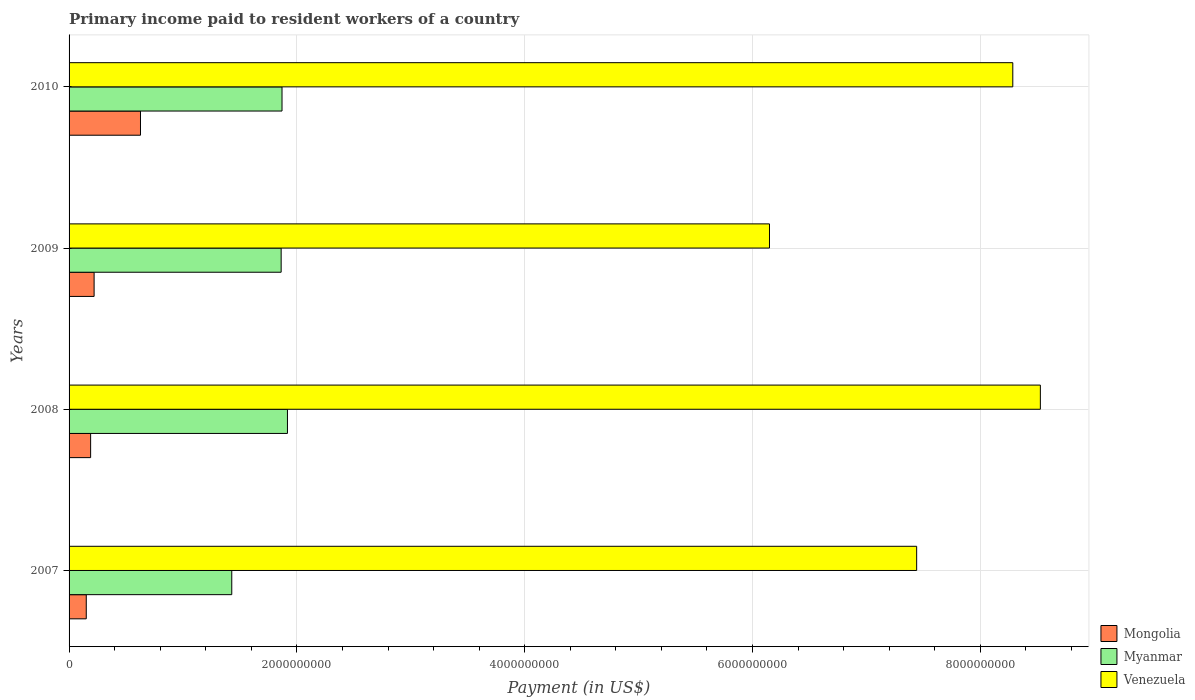How many groups of bars are there?
Give a very brief answer. 4. Are the number of bars on each tick of the Y-axis equal?
Make the answer very short. Yes. How many bars are there on the 1st tick from the top?
Your answer should be very brief. 3. In how many cases, is the number of bars for a given year not equal to the number of legend labels?
Your response must be concise. 0. What is the amount paid to workers in Mongolia in 2010?
Your response must be concise. 6.27e+08. Across all years, what is the maximum amount paid to workers in Myanmar?
Ensure brevity in your answer.  1.92e+09. Across all years, what is the minimum amount paid to workers in Venezuela?
Your answer should be compact. 6.15e+09. In which year was the amount paid to workers in Myanmar maximum?
Make the answer very short. 2008. What is the total amount paid to workers in Venezuela in the graph?
Provide a succinct answer. 3.04e+1. What is the difference between the amount paid to workers in Myanmar in 2007 and that in 2008?
Your response must be concise. -4.89e+08. What is the difference between the amount paid to workers in Myanmar in 2010 and the amount paid to workers in Mongolia in 2008?
Keep it short and to the point. 1.68e+09. What is the average amount paid to workers in Venezuela per year?
Give a very brief answer. 7.60e+09. In the year 2008, what is the difference between the amount paid to workers in Mongolia and amount paid to workers in Venezuela?
Keep it short and to the point. -8.34e+09. What is the ratio of the amount paid to workers in Venezuela in 2008 to that in 2009?
Your answer should be compact. 1.39. What is the difference between the highest and the second highest amount paid to workers in Myanmar?
Offer a very short reply. 4.77e+07. What is the difference between the highest and the lowest amount paid to workers in Venezuela?
Make the answer very short. 2.38e+09. What does the 1st bar from the top in 2008 represents?
Provide a short and direct response. Venezuela. What does the 1st bar from the bottom in 2007 represents?
Keep it short and to the point. Mongolia. Is it the case that in every year, the sum of the amount paid to workers in Myanmar and amount paid to workers in Venezuela is greater than the amount paid to workers in Mongolia?
Ensure brevity in your answer.  Yes. How many bars are there?
Make the answer very short. 12. Are all the bars in the graph horizontal?
Provide a short and direct response. Yes. How many legend labels are there?
Your answer should be very brief. 3. What is the title of the graph?
Offer a terse response. Primary income paid to resident workers of a country. What is the label or title of the X-axis?
Your response must be concise. Payment (in US$). What is the label or title of the Y-axis?
Keep it short and to the point. Years. What is the Payment (in US$) in Mongolia in 2007?
Offer a terse response. 1.51e+08. What is the Payment (in US$) of Myanmar in 2007?
Offer a very short reply. 1.43e+09. What is the Payment (in US$) of Venezuela in 2007?
Your response must be concise. 7.44e+09. What is the Payment (in US$) in Mongolia in 2008?
Keep it short and to the point. 1.89e+08. What is the Payment (in US$) in Myanmar in 2008?
Your response must be concise. 1.92e+09. What is the Payment (in US$) in Venezuela in 2008?
Give a very brief answer. 8.53e+09. What is the Payment (in US$) of Mongolia in 2009?
Provide a short and direct response. 2.20e+08. What is the Payment (in US$) of Myanmar in 2009?
Offer a terse response. 1.86e+09. What is the Payment (in US$) in Venezuela in 2009?
Your answer should be very brief. 6.15e+09. What is the Payment (in US$) of Mongolia in 2010?
Your answer should be compact. 6.27e+08. What is the Payment (in US$) in Myanmar in 2010?
Provide a succinct answer. 1.87e+09. What is the Payment (in US$) of Venezuela in 2010?
Your response must be concise. 8.28e+09. Across all years, what is the maximum Payment (in US$) of Mongolia?
Offer a terse response. 6.27e+08. Across all years, what is the maximum Payment (in US$) in Myanmar?
Your answer should be very brief. 1.92e+09. Across all years, what is the maximum Payment (in US$) of Venezuela?
Offer a terse response. 8.53e+09. Across all years, what is the minimum Payment (in US$) of Mongolia?
Give a very brief answer. 1.51e+08. Across all years, what is the minimum Payment (in US$) of Myanmar?
Provide a short and direct response. 1.43e+09. Across all years, what is the minimum Payment (in US$) in Venezuela?
Provide a succinct answer. 6.15e+09. What is the total Payment (in US$) in Mongolia in the graph?
Provide a short and direct response. 1.19e+09. What is the total Payment (in US$) of Myanmar in the graph?
Your answer should be compact. 7.08e+09. What is the total Payment (in US$) of Venezuela in the graph?
Your response must be concise. 3.04e+1. What is the difference between the Payment (in US$) of Mongolia in 2007 and that in 2008?
Ensure brevity in your answer.  -3.83e+07. What is the difference between the Payment (in US$) in Myanmar in 2007 and that in 2008?
Your response must be concise. -4.89e+08. What is the difference between the Payment (in US$) of Venezuela in 2007 and that in 2008?
Offer a terse response. -1.09e+09. What is the difference between the Payment (in US$) in Mongolia in 2007 and that in 2009?
Your answer should be very brief. -6.88e+07. What is the difference between the Payment (in US$) in Myanmar in 2007 and that in 2009?
Ensure brevity in your answer.  -4.34e+08. What is the difference between the Payment (in US$) in Venezuela in 2007 and that in 2009?
Keep it short and to the point. 1.29e+09. What is the difference between the Payment (in US$) of Mongolia in 2007 and that in 2010?
Ensure brevity in your answer.  -4.76e+08. What is the difference between the Payment (in US$) in Myanmar in 2007 and that in 2010?
Offer a terse response. -4.41e+08. What is the difference between the Payment (in US$) in Venezuela in 2007 and that in 2010?
Keep it short and to the point. -8.44e+08. What is the difference between the Payment (in US$) of Mongolia in 2008 and that in 2009?
Give a very brief answer. -3.05e+07. What is the difference between the Payment (in US$) of Myanmar in 2008 and that in 2009?
Offer a terse response. 5.53e+07. What is the difference between the Payment (in US$) in Venezuela in 2008 and that in 2009?
Offer a very short reply. 2.38e+09. What is the difference between the Payment (in US$) in Mongolia in 2008 and that in 2010?
Offer a very short reply. -4.38e+08. What is the difference between the Payment (in US$) in Myanmar in 2008 and that in 2010?
Your response must be concise. 4.77e+07. What is the difference between the Payment (in US$) of Venezuela in 2008 and that in 2010?
Ensure brevity in your answer.  2.42e+08. What is the difference between the Payment (in US$) of Mongolia in 2009 and that in 2010?
Ensure brevity in your answer.  -4.07e+08. What is the difference between the Payment (in US$) in Myanmar in 2009 and that in 2010?
Your response must be concise. -7.55e+06. What is the difference between the Payment (in US$) in Venezuela in 2009 and that in 2010?
Give a very brief answer. -2.14e+09. What is the difference between the Payment (in US$) in Mongolia in 2007 and the Payment (in US$) in Myanmar in 2008?
Your answer should be very brief. -1.77e+09. What is the difference between the Payment (in US$) of Mongolia in 2007 and the Payment (in US$) of Venezuela in 2008?
Offer a terse response. -8.38e+09. What is the difference between the Payment (in US$) in Myanmar in 2007 and the Payment (in US$) in Venezuela in 2008?
Offer a terse response. -7.10e+09. What is the difference between the Payment (in US$) in Mongolia in 2007 and the Payment (in US$) in Myanmar in 2009?
Your response must be concise. -1.71e+09. What is the difference between the Payment (in US$) in Mongolia in 2007 and the Payment (in US$) in Venezuela in 2009?
Make the answer very short. -6.00e+09. What is the difference between the Payment (in US$) of Myanmar in 2007 and the Payment (in US$) of Venezuela in 2009?
Offer a terse response. -4.72e+09. What is the difference between the Payment (in US$) of Mongolia in 2007 and the Payment (in US$) of Myanmar in 2010?
Offer a terse response. -1.72e+09. What is the difference between the Payment (in US$) of Mongolia in 2007 and the Payment (in US$) of Venezuela in 2010?
Provide a short and direct response. -8.13e+09. What is the difference between the Payment (in US$) of Myanmar in 2007 and the Payment (in US$) of Venezuela in 2010?
Your answer should be compact. -6.86e+09. What is the difference between the Payment (in US$) of Mongolia in 2008 and the Payment (in US$) of Myanmar in 2009?
Ensure brevity in your answer.  -1.67e+09. What is the difference between the Payment (in US$) in Mongolia in 2008 and the Payment (in US$) in Venezuela in 2009?
Your answer should be very brief. -5.96e+09. What is the difference between the Payment (in US$) of Myanmar in 2008 and the Payment (in US$) of Venezuela in 2009?
Offer a very short reply. -4.23e+09. What is the difference between the Payment (in US$) in Mongolia in 2008 and the Payment (in US$) in Myanmar in 2010?
Ensure brevity in your answer.  -1.68e+09. What is the difference between the Payment (in US$) of Mongolia in 2008 and the Payment (in US$) of Venezuela in 2010?
Provide a short and direct response. -8.10e+09. What is the difference between the Payment (in US$) of Myanmar in 2008 and the Payment (in US$) of Venezuela in 2010?
Provide a succinct answer. -6.37e+09. What is the difference between the Payment (in US$) in Mongolia in 2009 and the Payment (in US$) in Myanmar in 2010?
Your answer should be very brief. -1.65e+09. What is the difference between the Payment (in US$) in Mongolia in 2009 and the Payment (in US$) in Venezuela in 2010?
Offer a terse response. -8.07e+09. What is the difference between the Payment (in US$) in Myanmar in 2009 and the Payment (in US$) in Venezuela in 2010?
Your answer should be very brief. -6.42e+09. What is the average Payment (in US$) of Mongolia per year?
Give a very brief answer. 2.97e+08. What is the average Payment (in US$) in Myanmar per year?
Give a very brief answer. 1.77e+09. What is the average Payment (in US$) in Venezuela per year?
Your answer should be compact. 7.60e+09. In the year 2007, what is the difference between the Payment (in US$) in Mongolia and Payment (in US$) in Myanmar?
Provide a short and direct response. -1.28e+09. In the year 2007, what is the difference between the Payment (in US$) in Mongolia and Payment (in US$) in Venezuela?
Your response must be concise. -7.29e+09. In the year 2007, what is the difference between the Payment (in US$) in Myanmar and Payment (in US$) in Venezuela?
Offer a very short reply. -6.01e+09. In the year 2008, what is the difference between the Payment (in US$) of Mongolia and Payment (in US$) of Myanmar?
Ensure brevity in your answer.  -1.73e+09. In the year 2008, what is the difference between the Payment (in US$) in Mongolia and Payment (in US$) in Venezuela?
Provide a succinct answer. -8.34e+09. In the year 2008, what is the difference between the Payment (in US$) of Myanmar and Payment (in US$) of Venezuela?
Make the answer very short. -6.61e+09. In the year 2009, what is the difference between the Payment (in US$) in Mongolia and Payment (in US$) in Myanmar?
Provide a succinct answer. -1.64e+09. In the year 2009, what is the difference between the Payment (in US$) in Mongolia and Payment (in US$) in Venezuela?
Your answer should be very brief. -5.93e+09. In the year 2009, what is the difference between the Payment (in US$) in Myanmar and Payment (in US$) in Venezuela?
Provide a succinct answer. -4.29e+09. In the year 2010, what is the difference between the Payment (in US$) in Mongolia and Payment (in US$) in Myanmar?
Your answer should be compact. -1.24e+09. In the year 2010, what is the difference between the Payment (in US$) in Mongolia and Payment (in US$) in Venezuela?
Your answer should be very brief. -7.66e+09. In the year 2010, what is the difference between the Payment (in US$) in Myanmar and Payment (in US$) in Venezuela?
Make the answer very short. -6.42e+09. What is the ratio of the Payment (in US$) in Mongolia in 2007 to that in 2008?
Provide a short and direct response. 0.8. What is the ratio of the Payment (in US$) in Myanmar in 2007 to that in 2008?
Your response must be concise. 0.74. What is the ratio of the Payment (in US$) in Venezuela in 2007 to that in 2008?
Provide a succinct answer. 0.87. What is the ratio of the Payment (in US$) of Mongolia in 2007 to that in 2009?
Keep it short and to the point. 0.69. What is the ratio of the Payment (in US$) of Myanmar in 2007 to that in 2009?
Provide a short and direct response. 0.77. What is the ratio of the Payment (in US$) of Venezuela in 2007 to that in 2009?
Your answer should be very brief. 1.21. What is the ratio of the Payment (in US$) in Mongolia in 2007 to that in 2010?
Make the answer very short. 0.24. What is the ratio of the Payment (in US$) in Myanmar in 2007 to that in 2010?
Keep it short and to the point. 0.76. What is the ratio of the Payment (in US$) of Venezuela in 2007 to that in 2010?
Make the answer very short. 0.9. What is the ratio of the Payment (in US$) in Mongolia in 2008 to that in 2009?
Make the answer very short. 0.86. What is the ratio of the Payment (in US$) in Myanmar in 2008 to that in 2009?
Provide a short and direct response. 1.03. What is the ratio of the Payment (in US$) in Venezuela in 2008 to that in 2009?
Your response must be concise. 1.39. What is the ratio of the Payment (in US$) in Mongolia in 2008 to that in 2010?
Keep it short and to the point. 0.3. What is the ratio of the Payment (in US$) in Myanmar in 2008 to that in 2010?
Your answer should be very brief. 1.03. What is the ratio of the Payment (in US$) of Venezuela in 2008 to that in 2010?
Provide a short and direct response. 1.03. What is the ratio of the Payment (in US$) of Mongolia in 2009 to that in 2010?
Your answer should be very brief. 0.35. What is the ratio of the Payment (in US$) in Myanmar in 2009 to that in 2010?
Ensure brevity in your answer.  1. What is the ratio of the Payment (in US$) in Venezuela in 2009 to that in 2010?
Offer a terse response. 0.74. What is the difference between the highest and the second highest Payment (in US$) in Mongolia?
Offer a terse response. 4.07e+08. What is the difference between the highest and the second highest Payment (in US$) in Myanmar?
Provide a short and direct response. 4.77e+07. What is the difference between the highest and the second highest Payment (in US$) in Venezuela?
Your answer should be very brief. 2.42e+08. What is the difference between the highest and the lowest Payment (in US$) in Mongolia?
Offer a very short reply. 4.76e+08. What is the difference between the highest and the lowest Payment (in US$) in Myanmar?
Offer a very short reply. 4.89e+08. What is the difference between the highest and the lowest Payment (in US$) of Venezuela?
Give a very brief answer. 2.38e+09. 